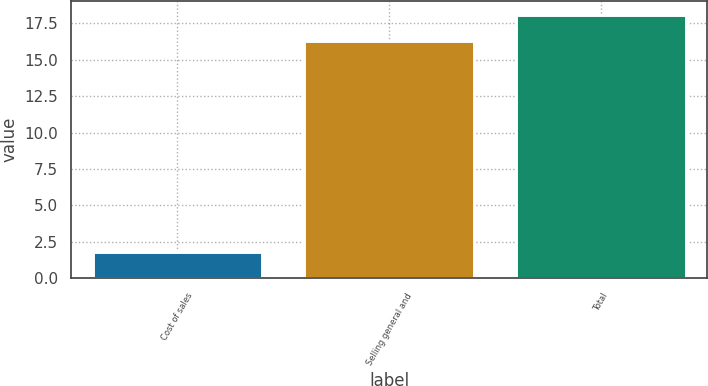<chart> <loc_0><loc_0><loc_500><loc_500><bar_chart><fcel>Cost of sales<fcel>Selling general and<fcel>Total<nl><fcel>1.8<fcel>16.3<fcel>18.1<nl></chart> 